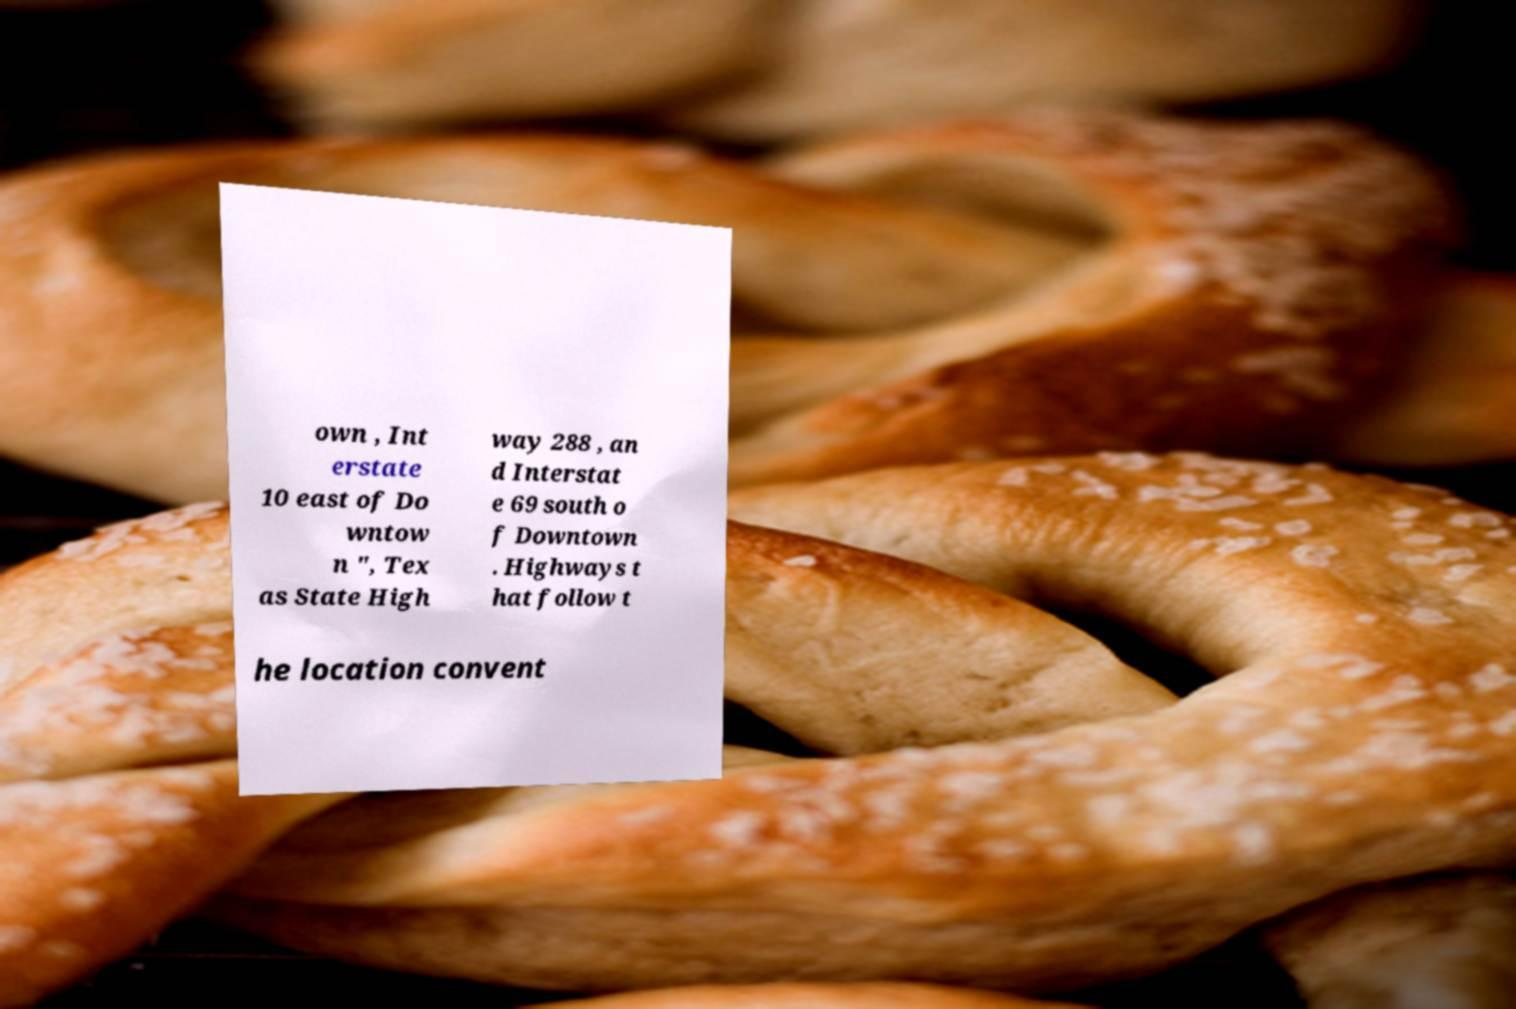Please identify and transcribe the text found in this image. own , Int erstate 10 east of Do wntow n ", Tex as State High way 288 , an d Interstat e 69 south o f Downtown . Highways t hat follow t he location convent 